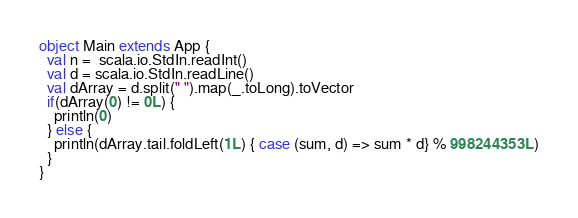Convert code to text. <code><loc_0><loc_0><loc_500><loc_500><_Scala_>object Main extends App {
  val n =  scala.io.StdIn.readInt()
  val d = scala.io.StdIn.readLine()
  val dArray = d.split(" ").map(_.toLong).toVector
  if(dArray(0) != 0L) {
    println(0)
  } else {
    println(dArray.tail.foldLeft(1L) { case (sum, d) => sum * d} % 998244353L)
  }
}
</code> 